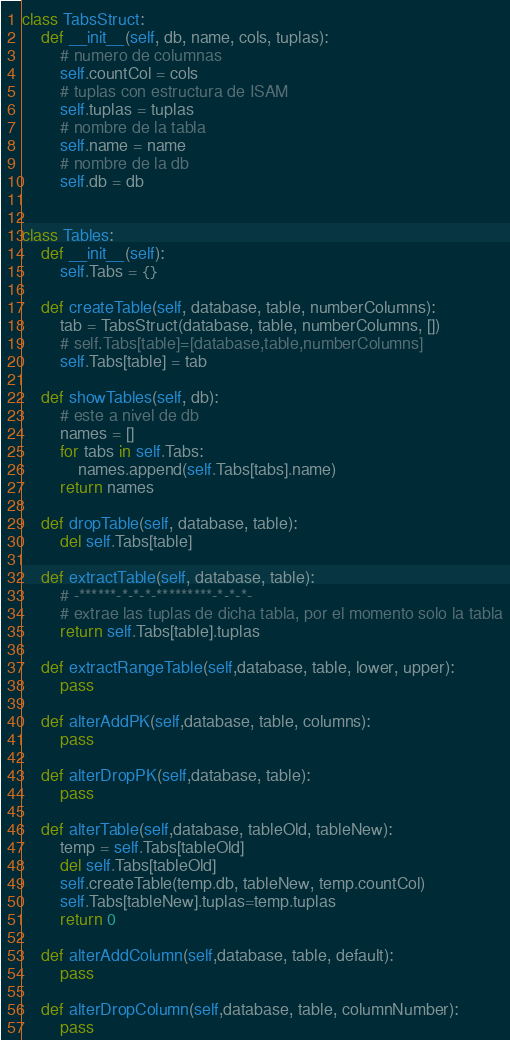<code> <loc_0><loc_0><loc_500><loc_500><_Python_>class TabsStruct:
    def __init__(self, db, name, cols, tuplas):
        # numero de columnas
        self.countCol = cols
        # tuplas con estructura de ISAM
        self.tuplas = tuplas
        # nombre de la tabla
        self.name = name
        # nombre de la db
        self.db = db


class Tables:
    def __init__(self):
        self.Tabs = {}

    def createTable(self, database, table, numberColumns):
        tab = TabsStruct(database, table, numberColumns, [])
        # self.Tabs[table]=[database,table,numberColumns]
        self.Tabs[table] = tab

    def showTables(self, db):
        # este a nivel de db
        names = []
        for tabs in self.Tabs:
            names.append(self.Tabs[tabs].name)
        return names

    def dropTable(self, database, table):
        del self.Tabs[table]

    def extractTable(self, database, table):
        # -******-*-*-*-*********-*-*-*-
        # extrae las tuplas de dicha tabla, por el momento solo la tabla
        return self.Tabs[table].tuplas

    def extractRangeTable(self,database, table, lower, upper):
        pass

    def alterAddPK(self,database, table, columns):
        pass

    def alterDropPK(self,database, table):
        pass

    def alterTable(self,database, tableOld, tableNew):
        temp = self.Tabs[tableOld]
        del self.Tabs[tableOld]
        self.createTable(temp.db, tableNew, temp.countCol)
        self.Tabs[tableNew].tuplas=temp.tuplas
        return 0

    def alterAddColumn(self,database, table, default):
        pass

    def alterDropColumn(self,database, table, columnNumber):
        pass
</code> 